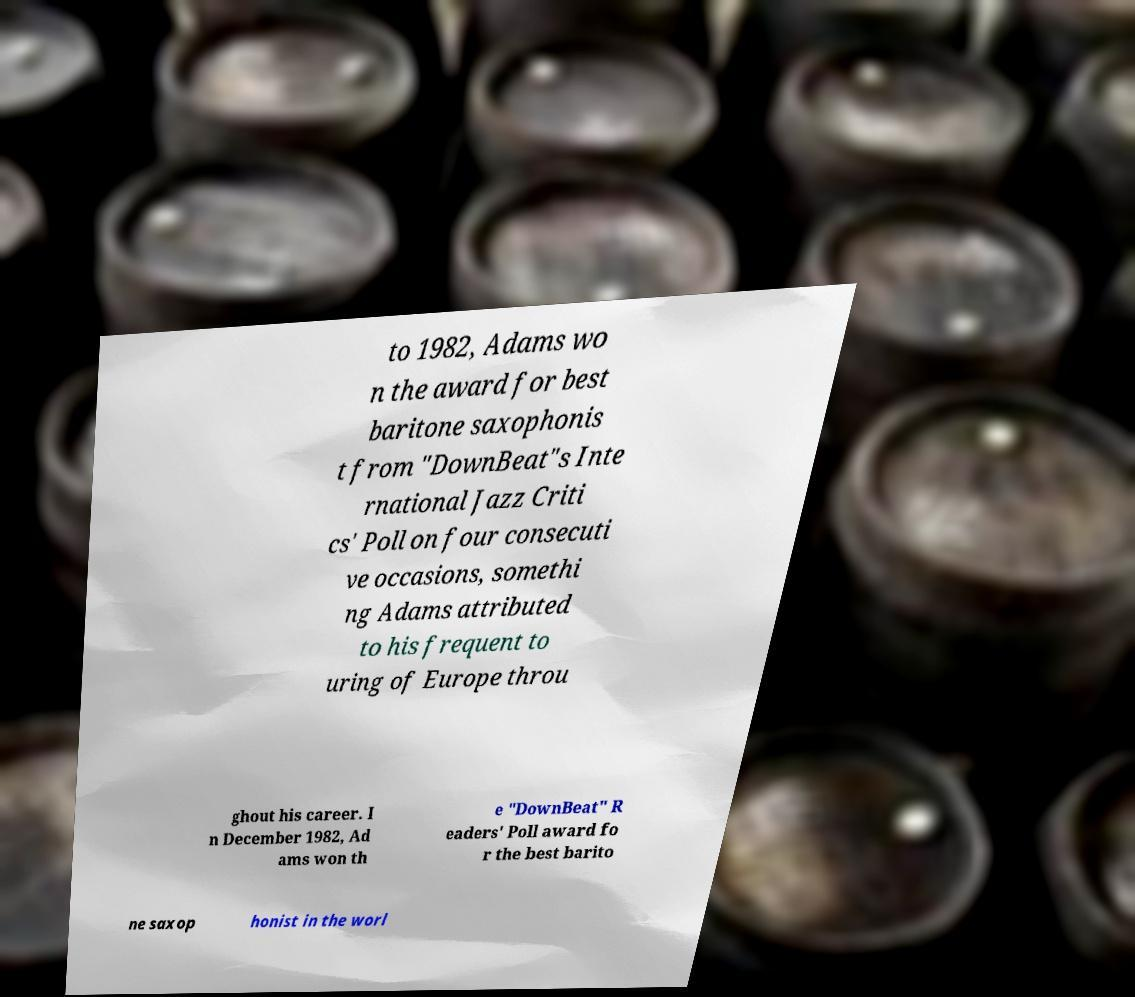Could you assist in decoding the text presented in this image and type it out clearly? to 1982, Adams wo n the award for best baritone saxophonis t from "DownBeat"s Inte rnational Jazz Criti cs' Poll on four consecuti ve occasions, somethi ng Adams attributed to his frequent to uring of Europe throu ghout his career. I n December 1982, Ad ams won th e "DownBeat" R eaders' Poll award fo r the best barito ne saxop honist in the worl 